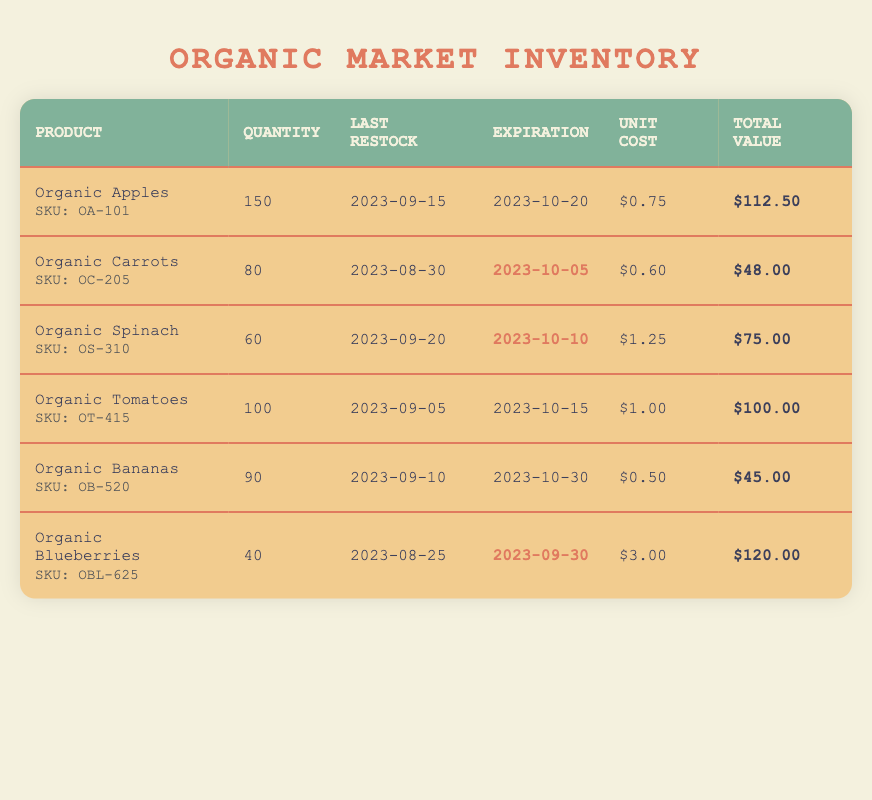What is the total quantity of Organic Apples on hand? The table shows that the quantity on hand for Organic Apples is listed directly in the corresponding row. From the data, it can be seen that the quantity is 150.
Answer: 150 When was the last restock date for Organic Carrots? The last restock date for each product is found in the "Last Restock" column, specifically for Organic Carrots, which is located in the same row. The date is 2023-08-30.
Answer: 2023-08-30 Which organic product has the highest total value? To find the product with the highest total value, we compare the values in the "Total Value" column. Organic Blueberries have a total value of 120, which is the highest compared to the others.
Answer: Organic Blueberries Are there any products with expiration dates approaching in October? By looking at the "Expiration" column, we can see the dates for all products. Organic Carrots and Organic Spinach are expiring in October. This confirms that there are products expiring soon.
Answer: Yes What is the average unit cost of the organic products listed in the table? To calculate the average unit cost, first sum all the individual unit costs: 0.75 + 0.60 + 1.25 + 1.00 + 0.50 + 3.00 = 6.10. Next, divide this sum by the number of products, which is 6. So the average unit cost is 6.10 / 6 = 1.02.
Answer: 1.02 What is the difference in quantity on hand between Organic Spinach and Organic Bananas? From the table, Organic Spinach has a quantity of 60, and Organic Bananas have 90. The difference is calculated by subtracting the quantity of Spinach from Bananas: 90 - 60 = 30.
Answer: 30 How many products are expiring before the end of September? Checking the "Expiration" column, Organic Blueberries expire on 2023-09-30, which is the only product expiring before October. Thus, only one product meets this criterion.
Answer: 1 Which product has the lowest quantity on hand, and how much is it? By reviewing the "Quantity" column, Organic Blueberries has the lowest quantity at 40 when compared to all other products.
Answer: Organic Blueberries, 40 Are there any products that were restocked after September 10, 2023? By examining the "Last Restock" dates, only Organic Spinach, which was restocked on 2023-09-20, comes after September 10. Therefore, there is a product that was restocked after this date.
Answer: Yes 